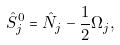<formula> <loc_0><loc_0><loc_500><loc_500>\hat { S } ^ { 0 } _ { j } = \hat { N } _ { j } - \frac { 1 } { 2 } \Omega _ { j } ,</formula> 